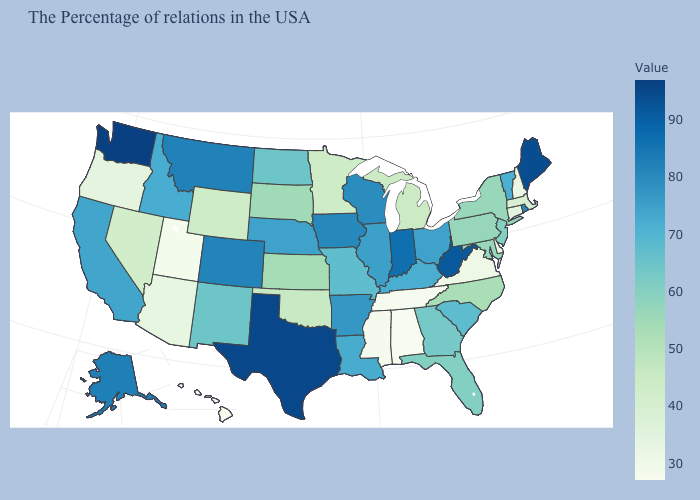Among the states that border California , which have the highest value?
Quick response, please. Nevada. Does New York have a lower value than Iowa?
Keep it brief. Yes. Which states have the lowest value in the USA?
Concise answer only. Hawaii. Among the states that border New Hampshire , does Vermont have the lowest value?
Give a very brief answer. No. Is the legend a continuous bar?
Quick response, please. Yes. Among the states that border Kentucky , does West Virginia have the highest value?
Give a very brief answer. Yes. 